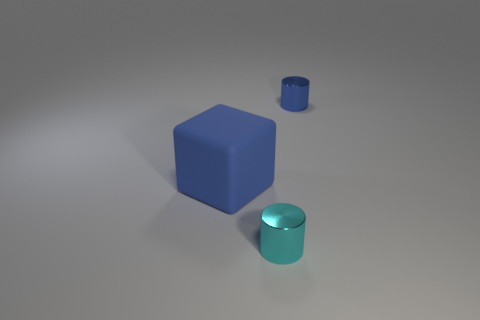Add 2 green balls. How many objects exist? 5 Subtract all cubes. How many objects are left? 2 Subtract 0 yellow blocks. How many objects are left? 3 Subtract all tiny cyan things. Subtract all small cyan cylinders. How many objects are left? 1 Add 2 blocks. How many blocks are left? 3 Add 1 small blue metallic cylinders. How many small blue metallic cylinders exist? 2 